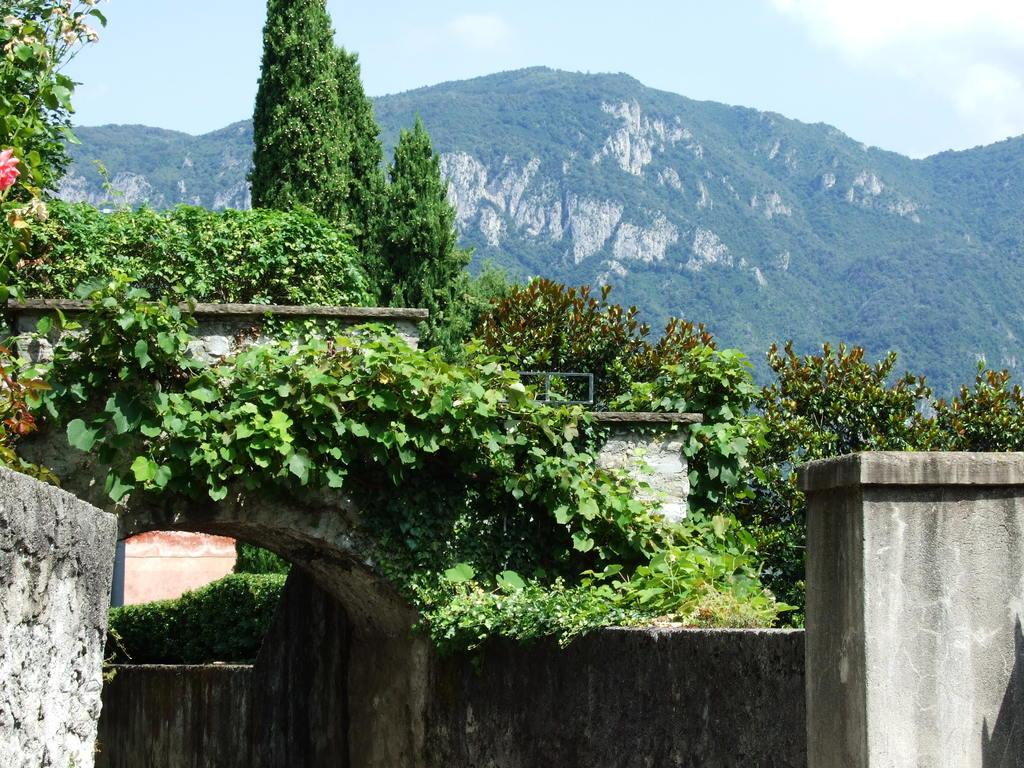What type of structures can be seen in the image? There are walls in the image. What type of vegetation is present in the image? There are plants and trees in the image. What can be seen in the background of the image? There is a hill and the sky visible in the background of the image. What is the weight of the tooth in the image? There is no tooth present in the image, so it is not possible to determine its weight. 